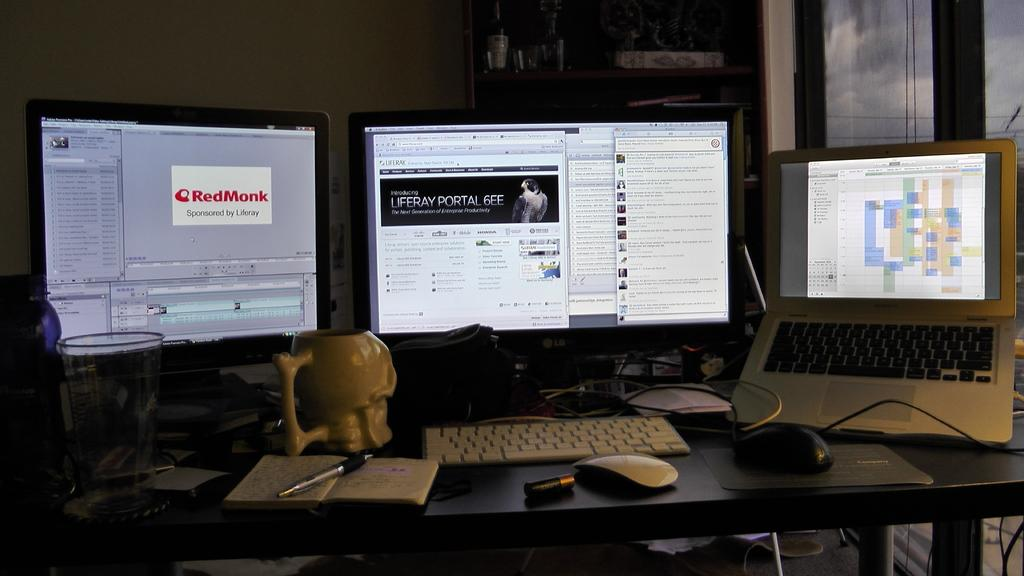<image>
Create a compact narrative representing the image presented. A computer display has a logo for RedMonk up on its screen. 